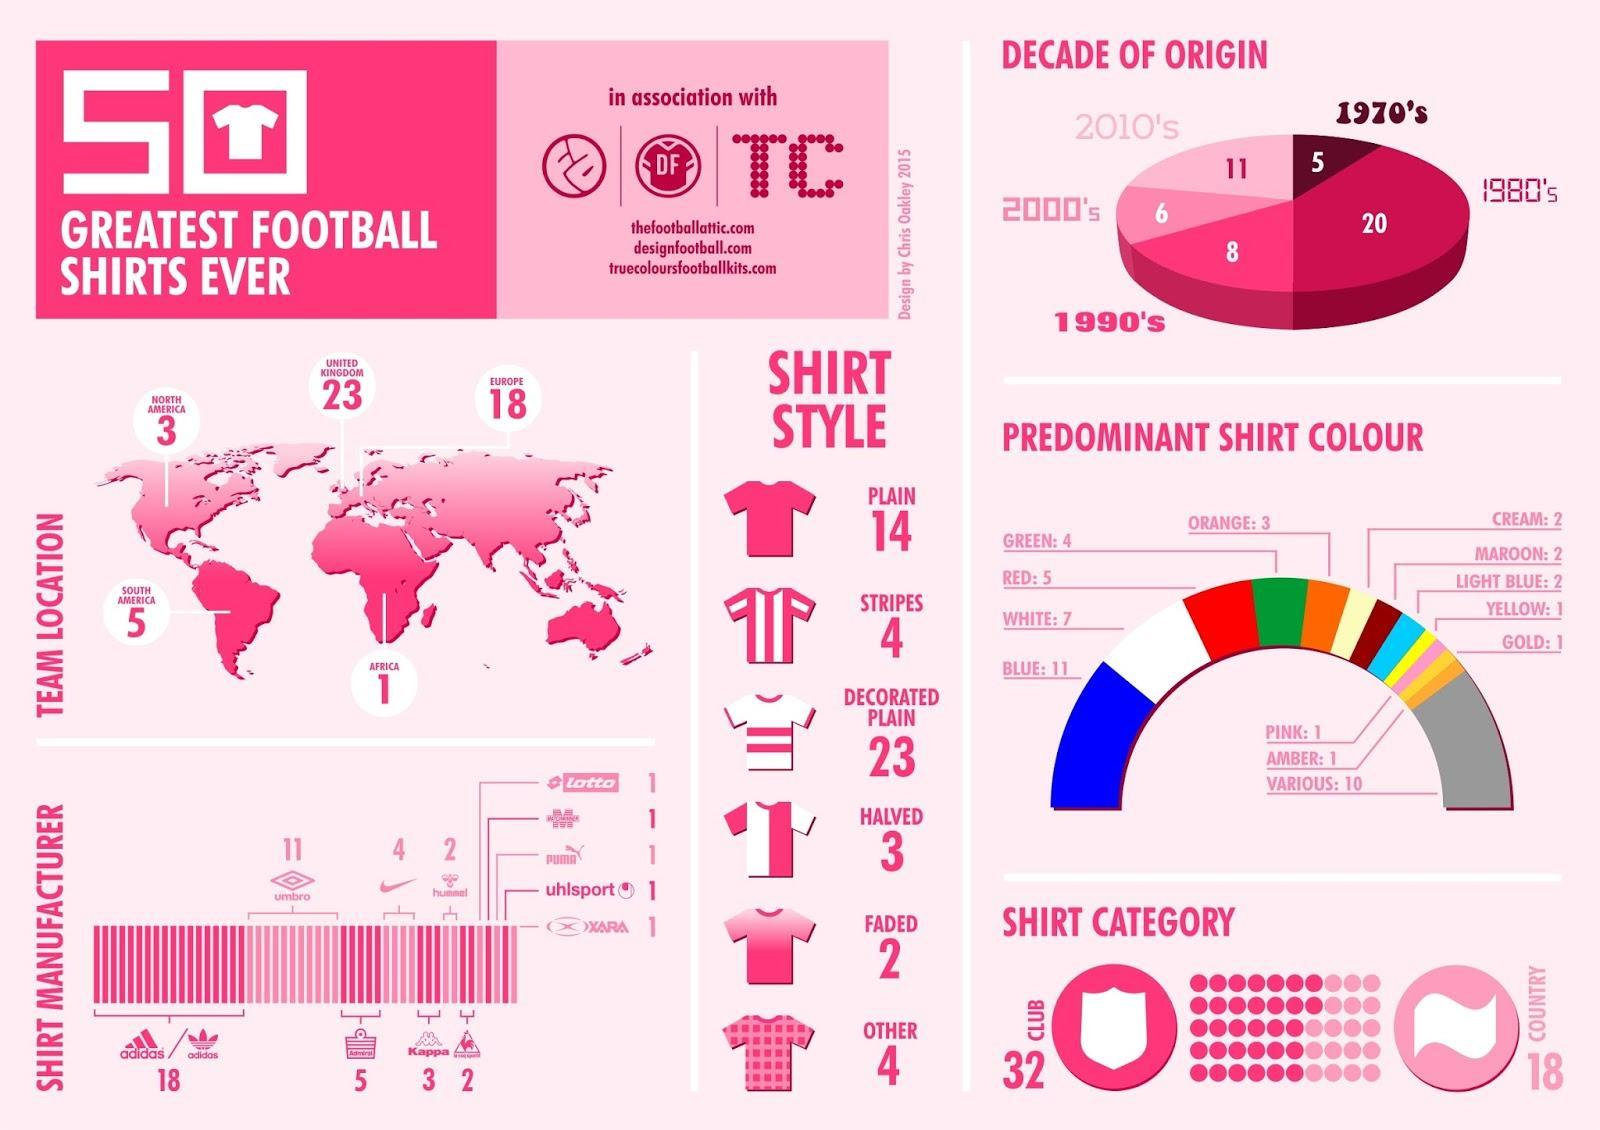What is the number of team locations in North America?
Answer the question with a short phrase. 3 What is the number of team locations in Africa? 1 What is the number of team locations in United Kingdom? 23 What is the fourth predominant shirt colour? red What is the number of team locations in South America? 5 What is the third predominant shirt colour? White 